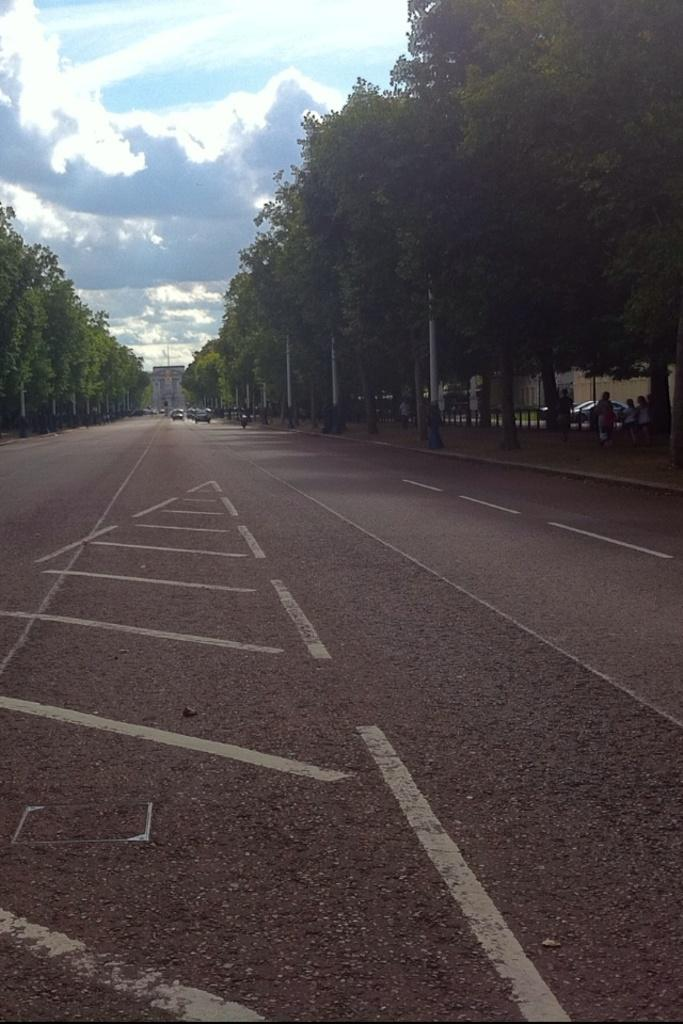What structures can be seen in the image? There are light poles in the image. What is happening on the road in the image? There are vehicles on the road in the image. What type of natural elements are present in the image? There are trees in the image. Who is present in the image? There is a group of people in the image. What can be seen in the background of the image? The sky is visible in the background of the image. What is the weather like in the image? The image appears to have been taken during a sunny day. What type of education is being provided to the visitors in the image? There are no visitors or educational activities present in the image. Who are the friends that can be seen interacting in the image? There is no mention of friends or any interactions between individuals in the image. 